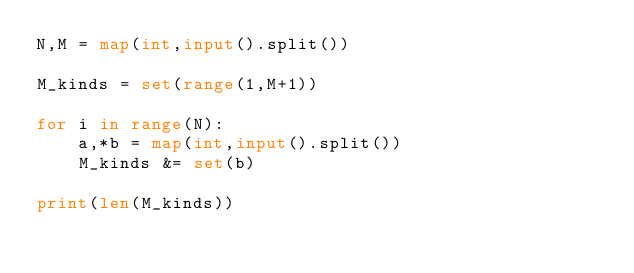<code> <loc_0><loc_0><loc_500><loc_500><_Python_>N,M = map(int,input().split())

M_kinds = set(range(1,M+1))

for i in range(N):
    a,*b = map(int,input().split())
    M_kinds &= set(b)

print(len(M_kinds))</code> 